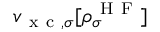<formula> <loc_0><loc_0><loc_500><loc_500>v _ { x c , \sigma } [ \rho _ { \sigma } ^ { H F } ]</formula> 